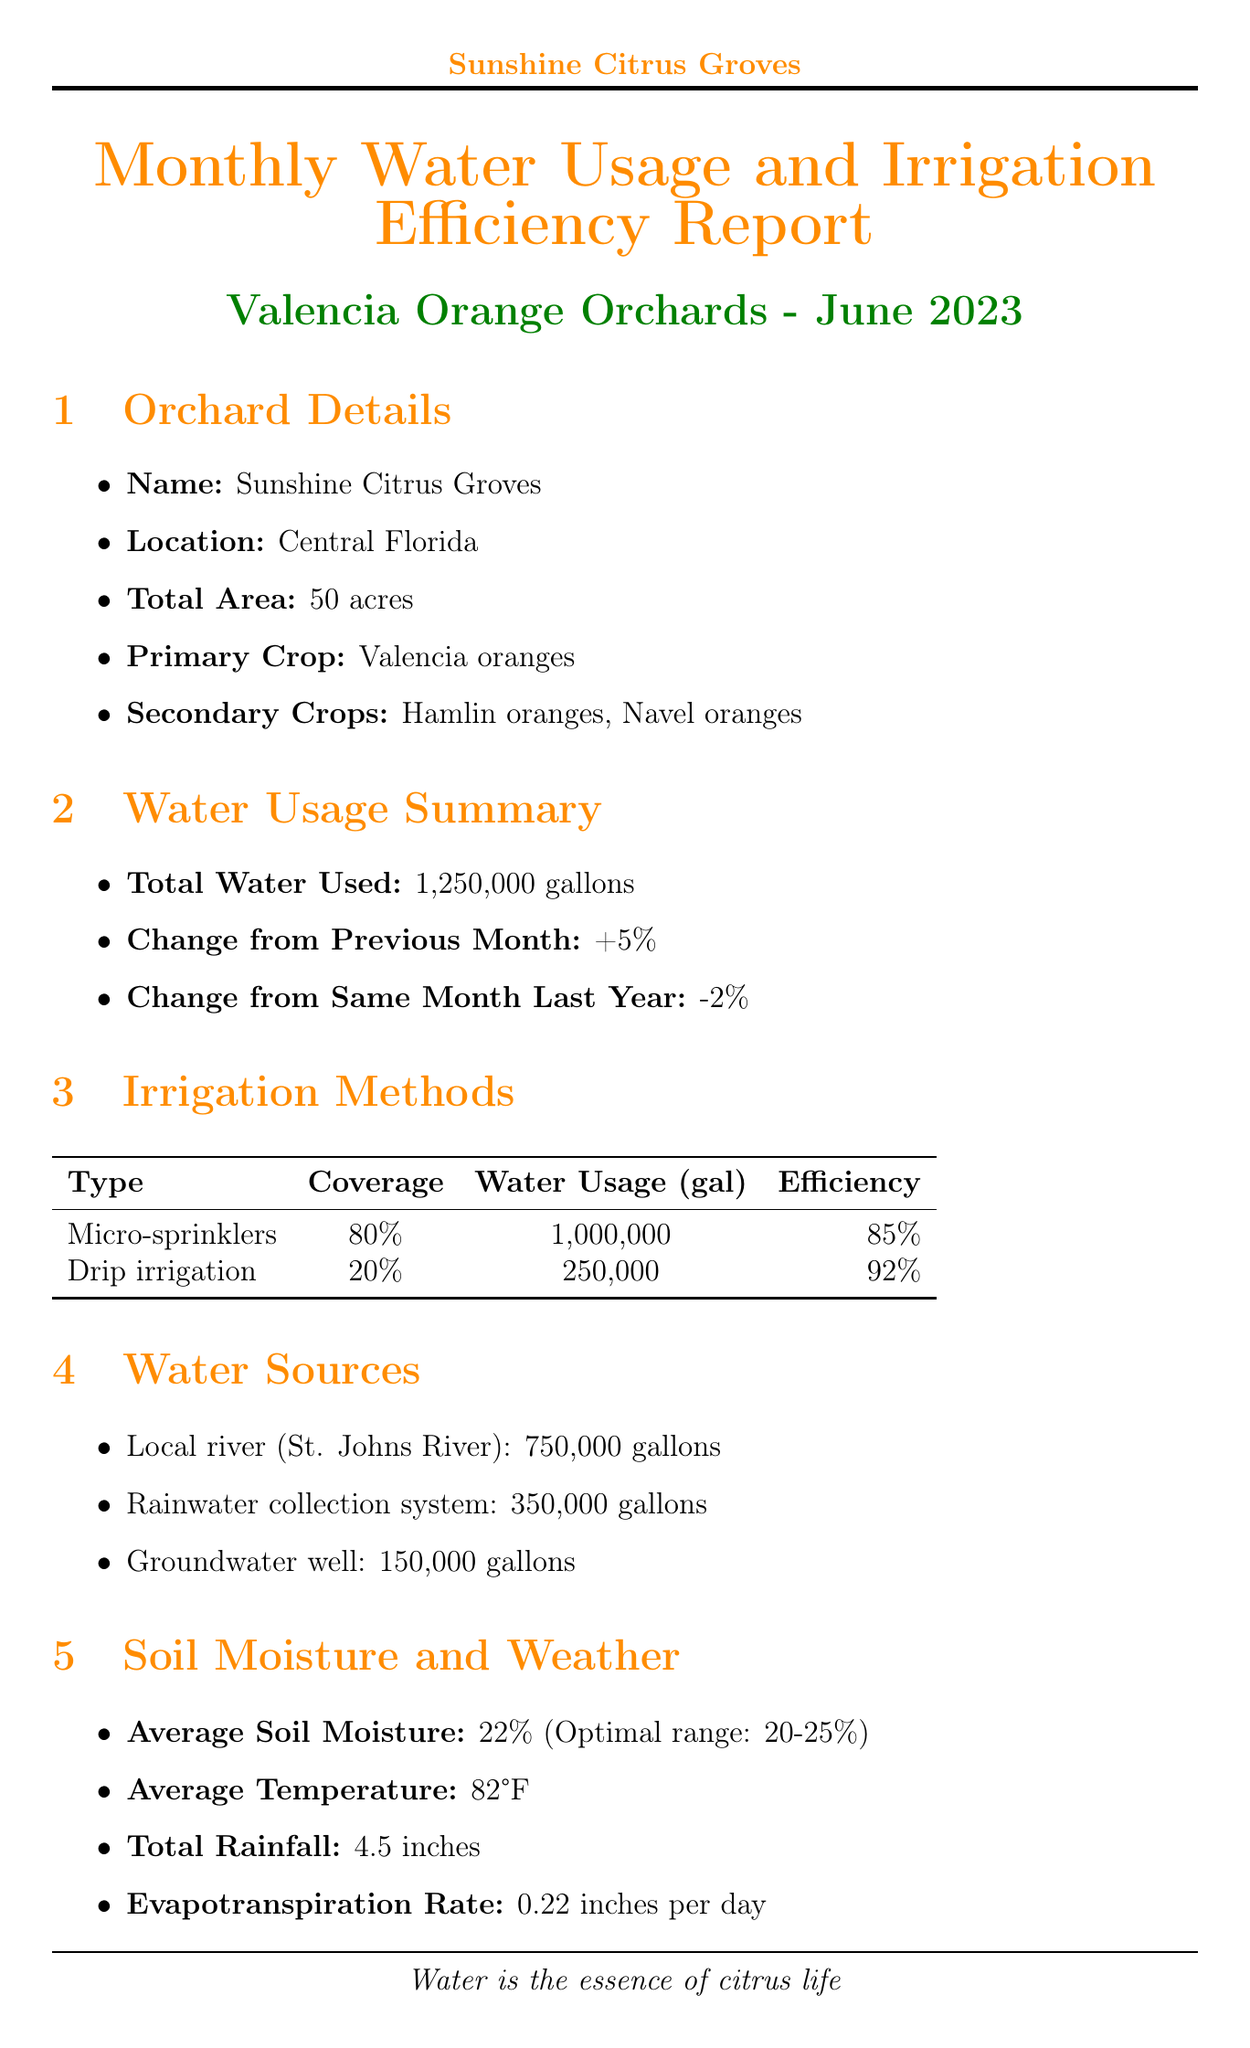What is the total water used? The total water used in the reporting period is clearly stated in the document.
Answer: 1,250,000 gallons What is the irrigation method with the highest efficiency rating? The document lists the efficiency ratings of different irrigation methods, and the highest rating can be found by comparing them.
Answer: Drip irrigation What is the average soil moisture level? The average soil moisture is specified in the document, and it can be directly retrieved from the relevant section.
Answer: 22% How much water is needed for the next month? The projected water needs for the next month are listed in the report, providing a specific figure.
Answer: 1,350,000 gallons What is the main source of water used? The document details various water sources, with the primary source indicated by the largest amount.
Answer: Local river (St. Johns River) What was the change in water usage from the previous month? The change in water usage is explicitly stated in the report, allowing for a quick answer.
Answer: +5% Which day of the week has irrigation scheduled? The schedule specifies the days, which can be easily found by listing them.
Answer: Monday What measure is recommended to reduce water evaporation? The report includes several water conservation measures, making it clear which specific measure addresses evaporation.
Answer: Use of mulch to reduce evaporation What was the last date for checking for leaks? The document states specific maintenance tasks and their last performed dates, making this information directly available.
Answer: June 28, 2023 